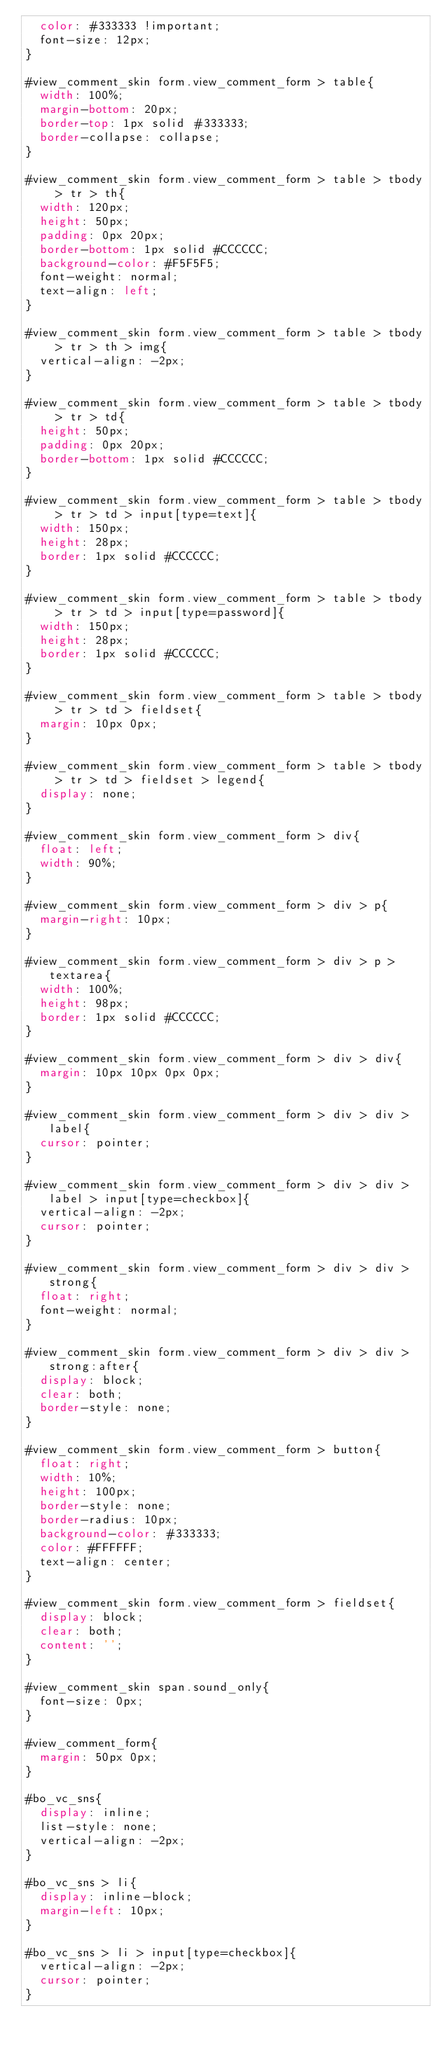<code> <loc_0><loc_0><loc_500><loc_500><_CSS_>	color: #333333 !important;
	font-size: 12px;
}

#view_comment_skin form.view_comment_form > table{
	width: 100%;
	margin-bottom: 20px;
	border-top: 1px solid #333333;
	border-collapse: collapse;
}

#view_comment_skin form.view_comment_form > table > tbody > tr > th{
	width: 120px;
	height: 50px;
	padding: 0px 20px;
	border-bottom: 1px solid #CCCCCC;
	background-color: #F5F5F5;
	font-weight: normal;
	text-align: left;
}

#view_comment_skin form.view_comment_form > table > tbody > tr > th > img{
	vertical-align: -2px;
}

#view_comment_skin form.view_comment_form > table > tbody > tr > td{
	height: 50px;
	padding: 0px 20px;
	border-bottom: 1px solid #CCCCCC;
}

#view_comment_skin form.view_comment_form > table > tbody > tr > td > input[type=text]{
	width: 150px;
	height: 28px;
	border: 1px solid #CCCCCC;
}

#view_comment_skin form.view_comment_form > table > tbody > tr > td > input[type=password]{
	width: 150px;
	height: 28px;
	border: 1px solid #CCCCCC;
}

#view_comment_skin form.view_comment_form > table > tbody > tr > td > fieldset{
	margin: 10px 0px;
}

#view_comment_skin form.view_comment_form > table > tbody > tr > td > fieldset > legend{
	display: none;
}

#view_comment_skin form.view_comment_form > div{
	float: left;
	width: 90%;
}

#view_comment_skin form.view_comment_form > div > p{
	margin-right: 10px;
}

#view_comment_skin form.view_comment_form > div > p > textarea{
	width: 100%;
	height: 98px;
	border: 1px solid #CCCCCC;
}

#view_comment_skin form.view_comment_form > div > div{
	margin: 10px 10px 0px 0px;
}

#view_comment_skin form.view_comment_form > div > div > label{
	cursor: pointer;
}

#view_comment_skin form.view_comment_form > div > div > label > input[type=checkbox]{
	vertical-align: -2px;
	cursor: pointer;
}

#view_comment_skin form.view_comment_form > div > div > strong{
	float: right;
	font-weight: normal;
}

#view_comment_skin form.view_comment_form > div > div > strong:after{
	display: block;
	clear: both;
	border-style: none;
}

#view_comment_skin form.view_comment_form > button{
	float: right;
	width: 10%;
	height: 100px;
	border-style: none;
	border-radius: 10px;
	background-color: #333333;
	color: #FFFFFF;
	text-align: center;
}

#view_comment_skin form.view_comment_form > fieldset{
	display: block;
	clear: both;
	content: '';
}

#view_comment_skin span.sound_only{
	font-size: 0px;
}

#view_comment_form{
	margin: 50px 0px;
}

#bo_vc_sns{
	display: inline;
	list-style: none;
	vertical-align: -2px;
}

#bo_vc_sns > li{
	display: inline-block;
	margin-left: 10px;
}

#bo_vc_sns > li > input[type=checkbox]{
	vertical-align: -2px;
	cursor: pointer;
}</code> 